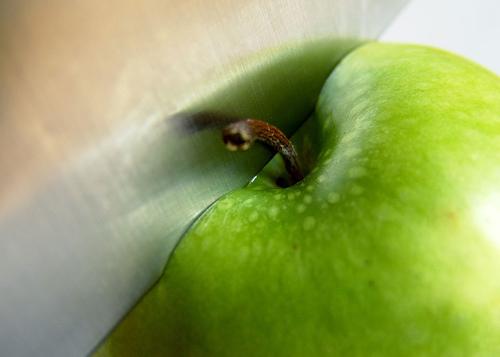Is the apple red?
Be succinct. No. Is this the right utensil for the job?
Write a very short answer. Yes. What is going to happen to the apple?
Keep it brief. Cut. 